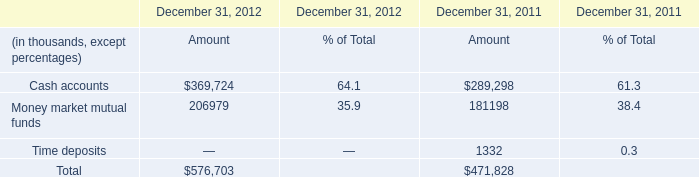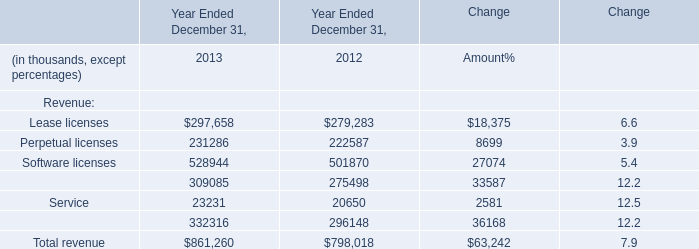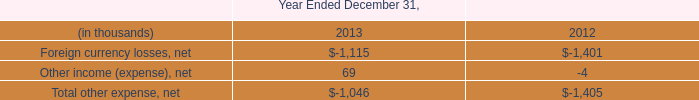What's the sum of Maintenance and service of Year Ended December 31, 2012, and Cash accounts of December 31, 2012 Amount ? 
Computations: (296148.0 + 369724.0)
Answer: 665872.0. 